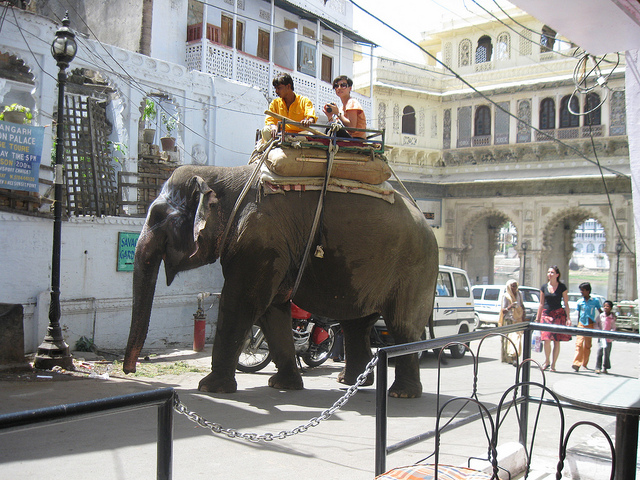Please transcribe the text in this image. ANGAR N PALACE 